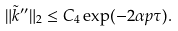Convert formula to latex. <formula><loc_0><loc_0><loc_500><loc_500>\| \tilde { k } ^ { \prime \prime } \| _ { 2 } \leq C _ { 4 } \exp ( - 2 \alpha p \tau ) .</formula> 